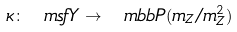<formula> <loc_0><loc_0><loc_500><loc_500>\kappa \colon \ m s f { Y } \to \ m b b { P } ( m _ { Z } / m _ { Z } ^ { 2 } )</formula> 